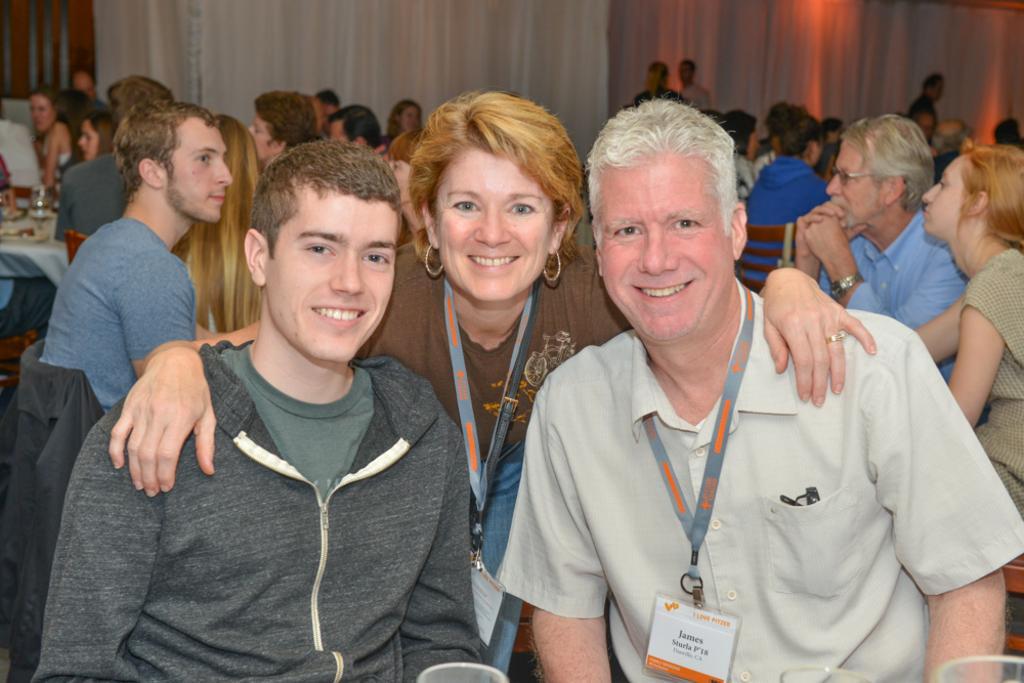How would you summarize this image in a sentence or two? This picture describes about group of people, few are seated and few are standing, on the left side of the image we can see a glass and other things on the table, and few people wore tags, in the background we can see curtains. 